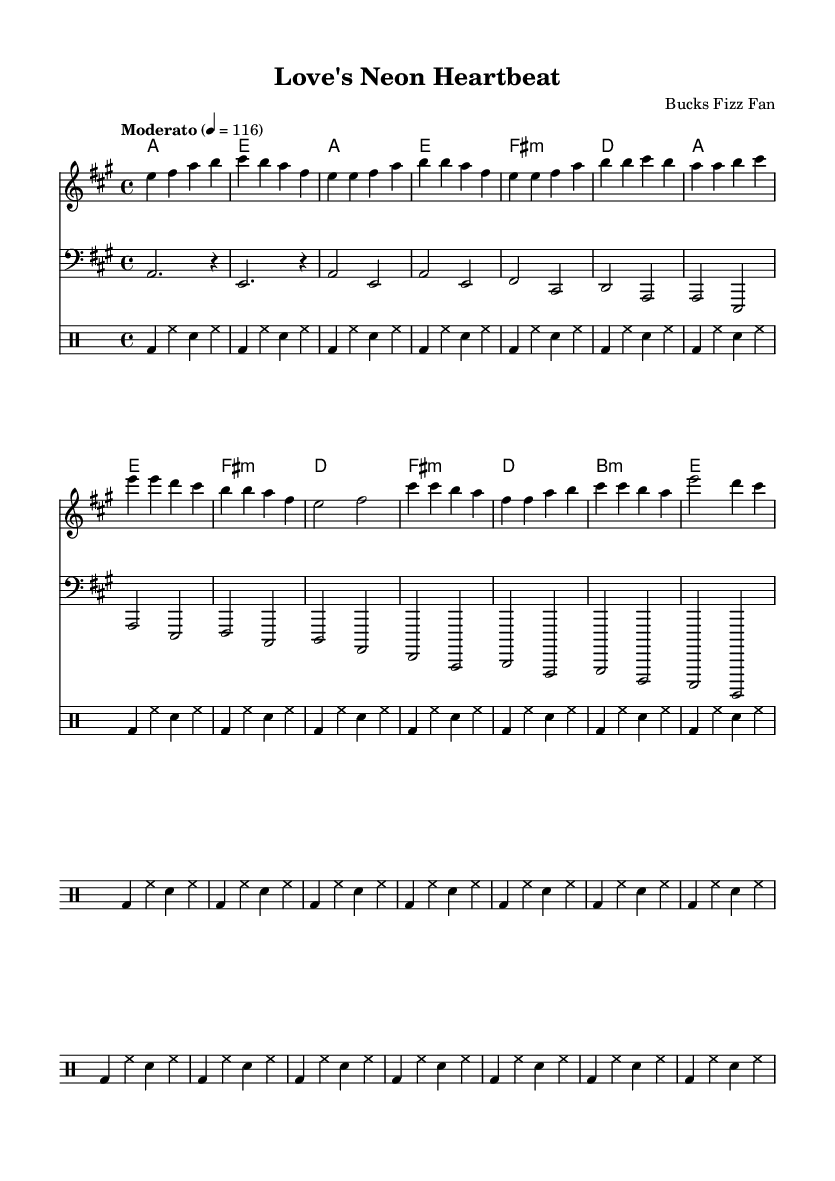What is the key signature of this music? The key signature is A major, indicated by three sharps (F#, C#, and G#) in the beginning of the staff.
Answer: A major What is the time signature of the piece? The time signature is 4/4, which means there are four beats in each measure and a quarter note gets one beat.
Answer: 4/4 What is the tempo marking for the piece? The tempo is marked as "Moderato," which typically refers to a moderate speed of 116 beats per minute as shown in the score.
Answer: Moderato How many measures are present in the chorus section? The chorus section is comprised of four measures, which can be identified by counting the notated segments in that part of the sheet music.
Answer: 4 What is the main theme of the lyrics? The lyrics describe young romance, emphasizing feelings of love, connection, and the excitement of a new relationship.
Answer: Young romance What is the first chord played in the song? The first chord is A major, as noted in the harmonies section right at the beginning of the score.
Answer: A major What type of drum pattern is used throughout the piece? The drum pattern consists of a bass drum, hi-hat, and snare in a consistent rhythmic pattern, indicative of a typical synth-pop style.
Answer: Synth-pop 